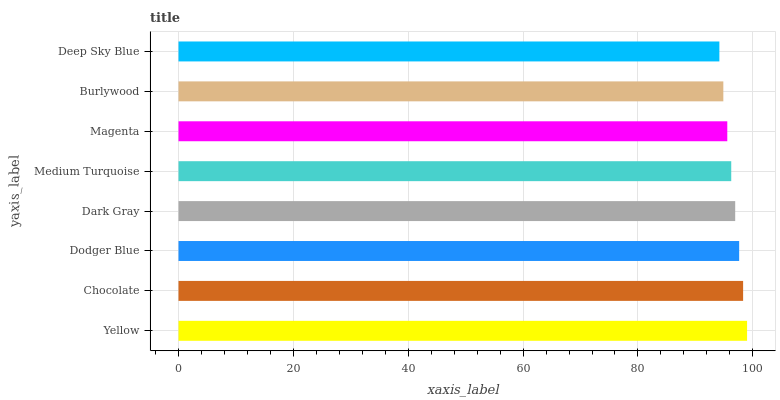Is Deep Sky Blue the minimum?
Answer yes or no. Yes. Is Yellow the maximum?
Answer yes or no. Yes. Is Chocolate the minimum?
Answer yes or no. No. Is Chocolate the maximum?
Answer yes or no. No. Is Yellow greater than Chocolate?
Answer yes or no. Yes. Is Chocolate less than Yellow?
Answer yes or no. Yes. Is Chocolate greater than Yellow?
Answer yes or no. No. Is Yellow less than Chocolate?
Answer yes or no. No. Is Dark Gray the high median?
Answer yes or no. Yes. Is Medium Turquoise the low median?
Answer yes or no. Yes. Is Deep Sky Blue the high median?
Answer yes or no. No. Is Dodger Blue the low median?
Answer yes or no. No. 